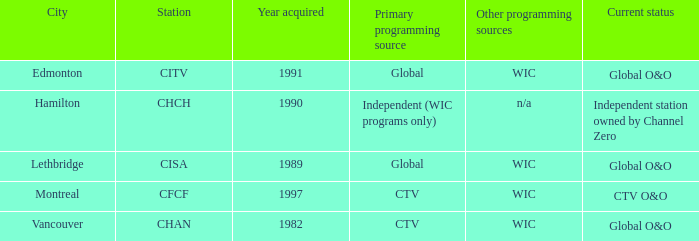How many is the minimum for citv 1991.0. Parse the table in full. {'header': ['City', 'Station', 'Year acquired', 'Primary programming source', 'Other programming sources', 'Current status'], 'rows': [['Edmonton', 'CITV', '1991', 'Global', 'WIC', 'Global O&O'], ['Hamilton', 'CHCH', '1990', 'Independent (WIC programs only)', 'n/a', 'Independent station owned by Channel Zero'], ['Lethbridge', 'CISA', '1989', 'Global', 'WIC', 'Global O&O'], ['Montreal', 'CFCF', '1997', 'CTV', 'WIC', 'CTV O&O'], ['Vancouver', 'CHAN', '1982', 'CTV', 'WIC', 'Global O&O']]} 